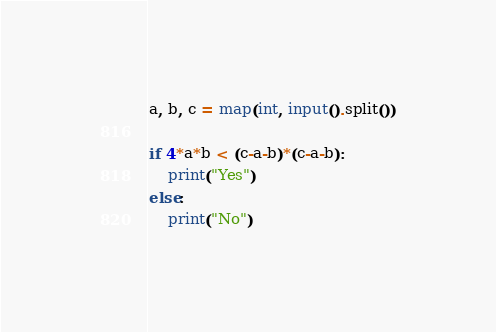<code> <loc_0><loc_0><loc_500><loc_500><_Python_>a, b, c = map(int, input().split())

if 4*a*b < (c-a-b)*(c-a-b):
    print("Yes")
else:
    print("No")
</code> 